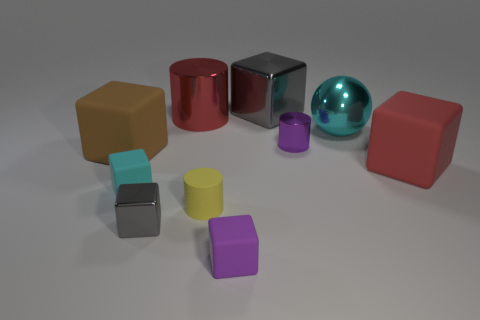Subtract all cyan blocks. How many blocks are left? 5 Subtract all red matte cubes. How many cubes are left? 5 Subtract all red blocks. Subtract all gray cylinders. How many blocks are left? 5 Subtract all spheres. How many objects are left? 9 Subtract all cyan rubber cubes. Subtract all gray shiny objects. How many objects are left? 7 Add 5 gray metallic cubes. How many gray metallic cubes are left? 7 Add 5 small metal cylinders. How many small metal cylinders exist? 6 Subtract 1 purple blocks. How many objects are left? 9 